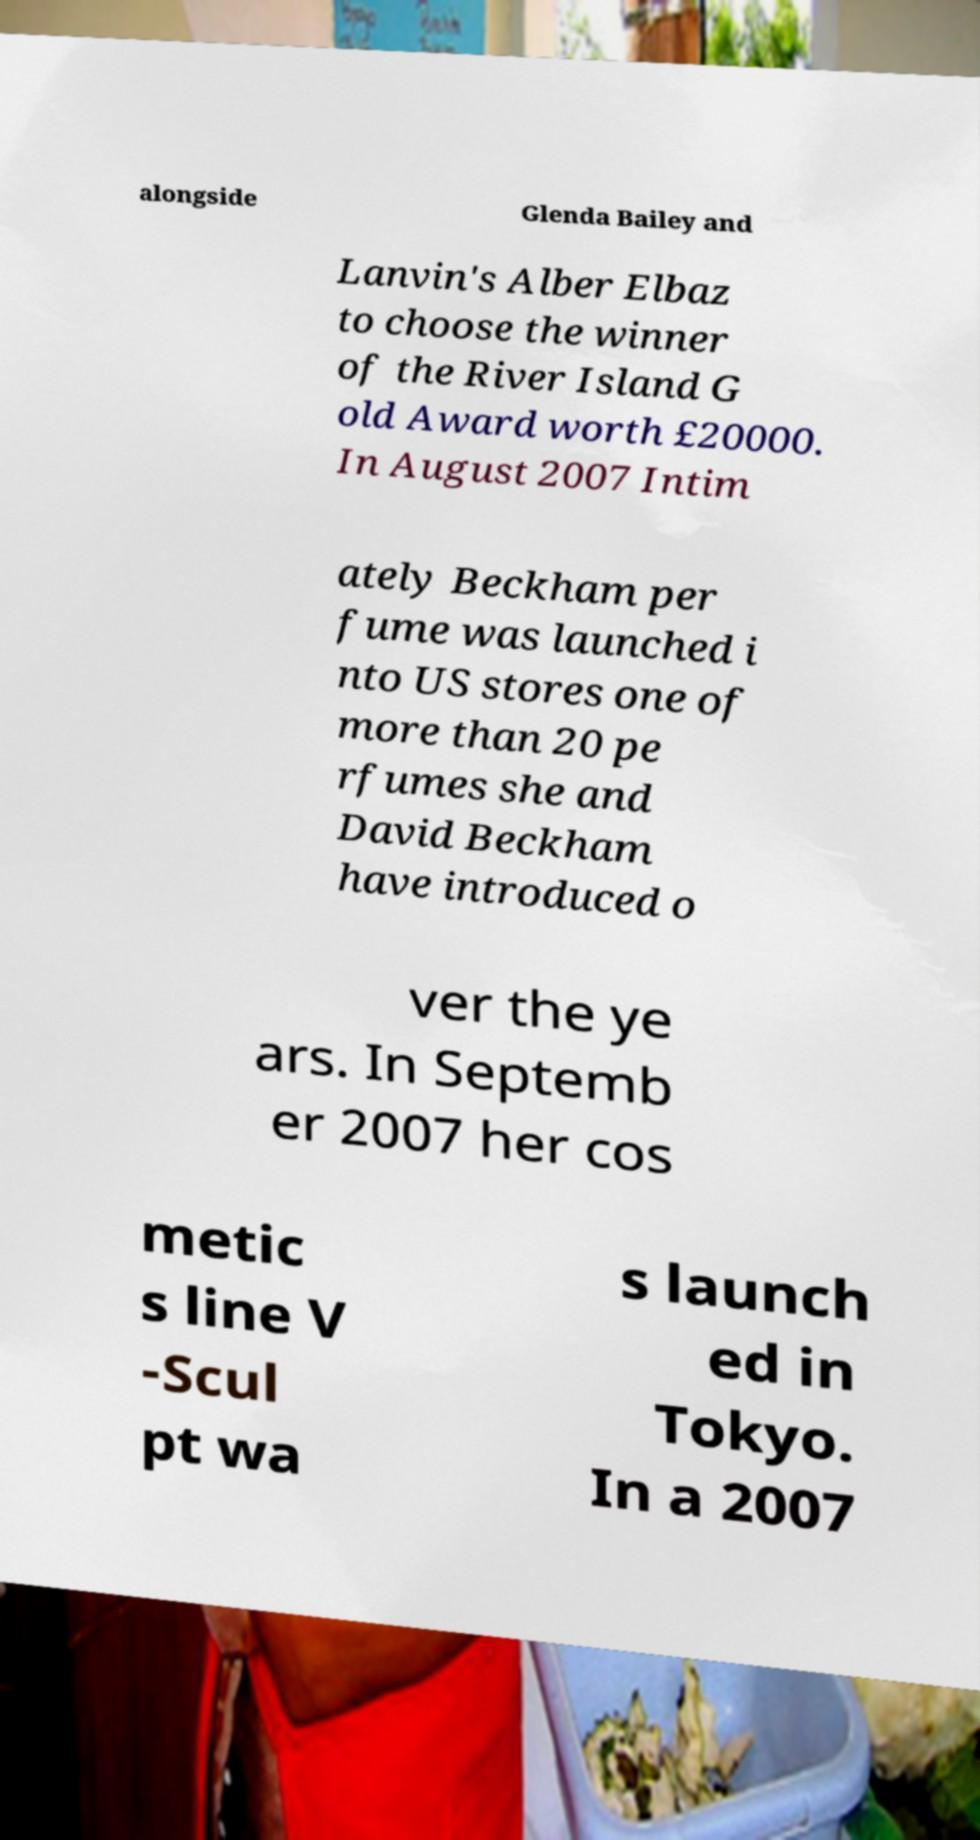There's text embedded in this image that I need extracted. Can you transcribe it verbatim? alongside Glenda Bailey and Lanvin's Alber Elbaz to choose the winner of the River Island G old Award worth £20000. In August 2007 Intim ately Beckham per fume was launched i nto US stores one of more than 20 pe rfumes she and David Beckham have introduced o ver the ye ars. In Septemb er 2007 her cos metic s line V -Scul pt wa s launch ed in Tokyo. In a 2007 